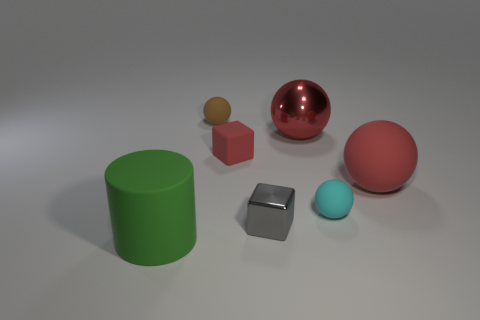Subtract all blocks. How many objects are left? 5 Subtract 1 cylinders. How many cylinders are left? 0 Subtract all green cubes. Subtract all cyan balls. How many cubes are left? 2 Subtract all blue cylinders. How many brown balls are left? 1 Subtract all tiny cyan rubber objects. Subtract all red blocks. How many objects are left? 5 Add 3 matte objects. How many matte objects are left? 8 Add 5 red cylinders. How many red cylinders exist? 5 Add 3 green rubber cylinders. How many objects exist? 10 Subtract all red blocks. How many blocks are left? 1 Subtract all small brown rubber balls. How many balls are left? 3 